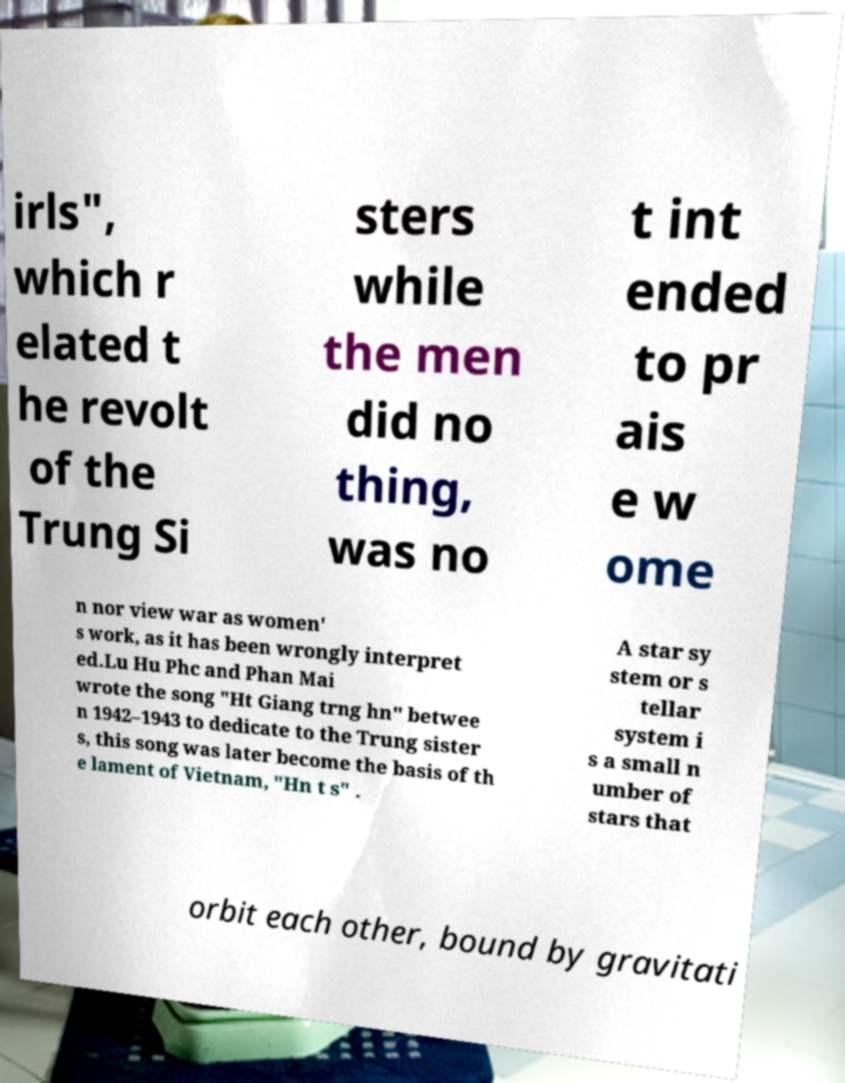Could you assist in decoding the text presented in this image and type it out clearly? irls", which r elated t he revolt of the Trung Si sters while the men did no thing, was no t int ended to pr ais e w ome n nor view war as women' s work, as it has been wrongly interpret ed.Lu Hu Phc and Phan Mai wrote the song "Ht Giang trng hn" betwee n 1942–1943 to dedicate to the Trung sister s, this song was later become the basis of th e lament of Vietnam, "Hn t s" . A star sy stem or s tellar system i s a small n umber of stars that orbit each other, bound by gravitati 